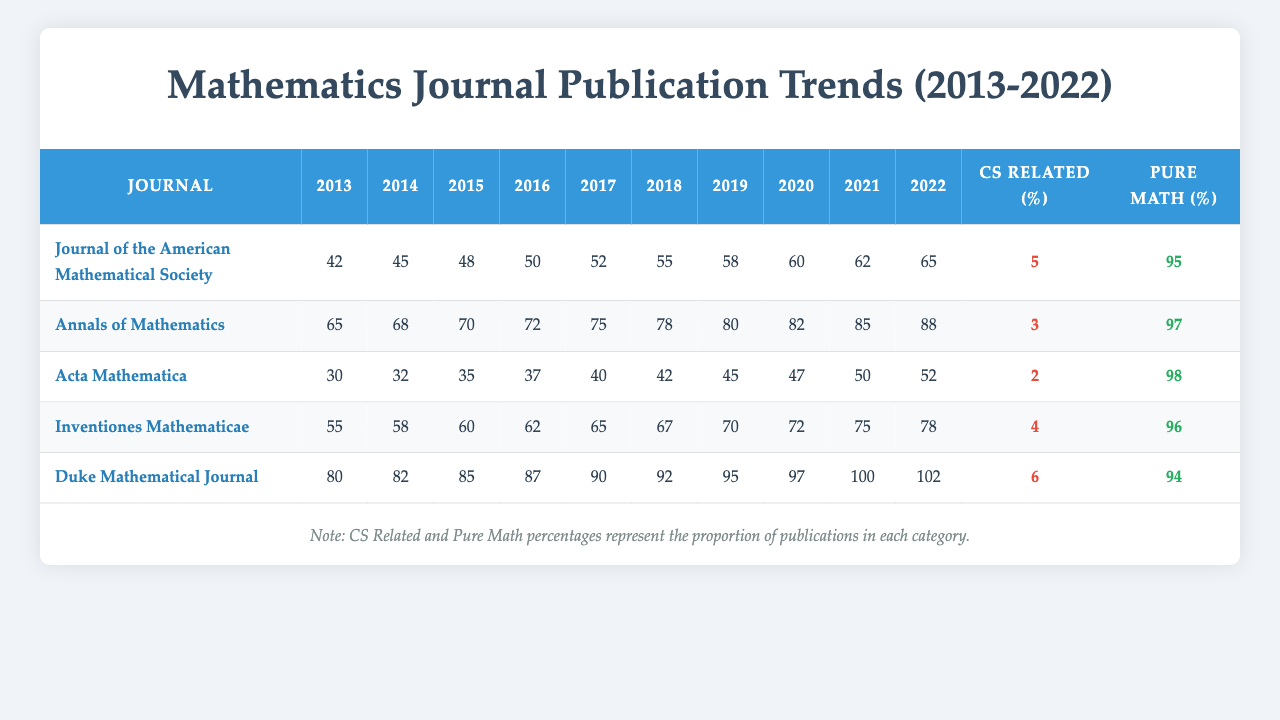What was the total number of publications in the Duke Mathematical Journal in 2015? Referring to the table under the "Duke Mathematical Journal" row and the year 2015, the total number of publications is 85.
Answer: 85 How many publications did the Annals of Mathematics have in the year 2020? Looking at the row for the Annals of Mathematics under the year 2020, the number of publications is 82.
Answer: 82 Which journal had the highest number of publications in 2022? Reviewing the table for the year 2022, the Duke Mathematical Journal has 102 publications, which is the highest among all listed journals.
Answer: Duke Mathematical Journal What percentage of the publications in Inventiones Mathematicae in 2022 were related to computer science? The table indicates that there are 78 total publications in Inventiones Mathematicae in 2022 and 4 of those are computer science related. The percentage is calculated as (4/78)*100 which is approximately 5.13%.
Answer: 5.13% What is the average number of publications for Acta Mathematica over the 10-year period from 2013 to 2022? To find the average, sum the values for Acta Mathematica across each year: 30 + 32 + 35 + 37 + 40 + 42 + 45 + 47 + 50 + 52 =  420. Then divide 420 by 10 years, which gives an average of 42.
Answer: 42 Which journal had the smallest number of computer science-related publications? By comparing the "computer_science_related" values across all journals, Acta Mathematica has the smallest number at 2 publications.
Answer: Acta Mathematica Is the number of publications in the Journal of the American Mathematical Society in 2019 greater than those in 2016? The number of publications for the Journal of the American Mathematical Society in 2019 is 58, while in 2016 it is 50. Therefore, yes, 58 is greater than 50.
Answer: Yes Which journal has the highest percentage of pure mathematics publications? Comparing the "pure_math" values, Acta Mathematica has the highest percentage at 98%.
Answer: Acta Mathematica How many total publications were made across all journals in 2021? Adding the totals for each journal in 2021 gives: 62 + 85 + 50 + 75 + 100 = 372.
Answer: 372 Did Ngô Bảo Châu have more or less than 50 publications? Based on the data, Ngô Bảo Châu has 62 publications, which is more than 50.
Answer: More What is the trend in the number of publications for the Duke Mathematical Journal over the years? Observing the values, the number of publications for Duke Mathematical Journal shows a consistent increase each year from 80 in 2013 to 102 in 2022, indicating a positive trend.
Answer: Increasing 